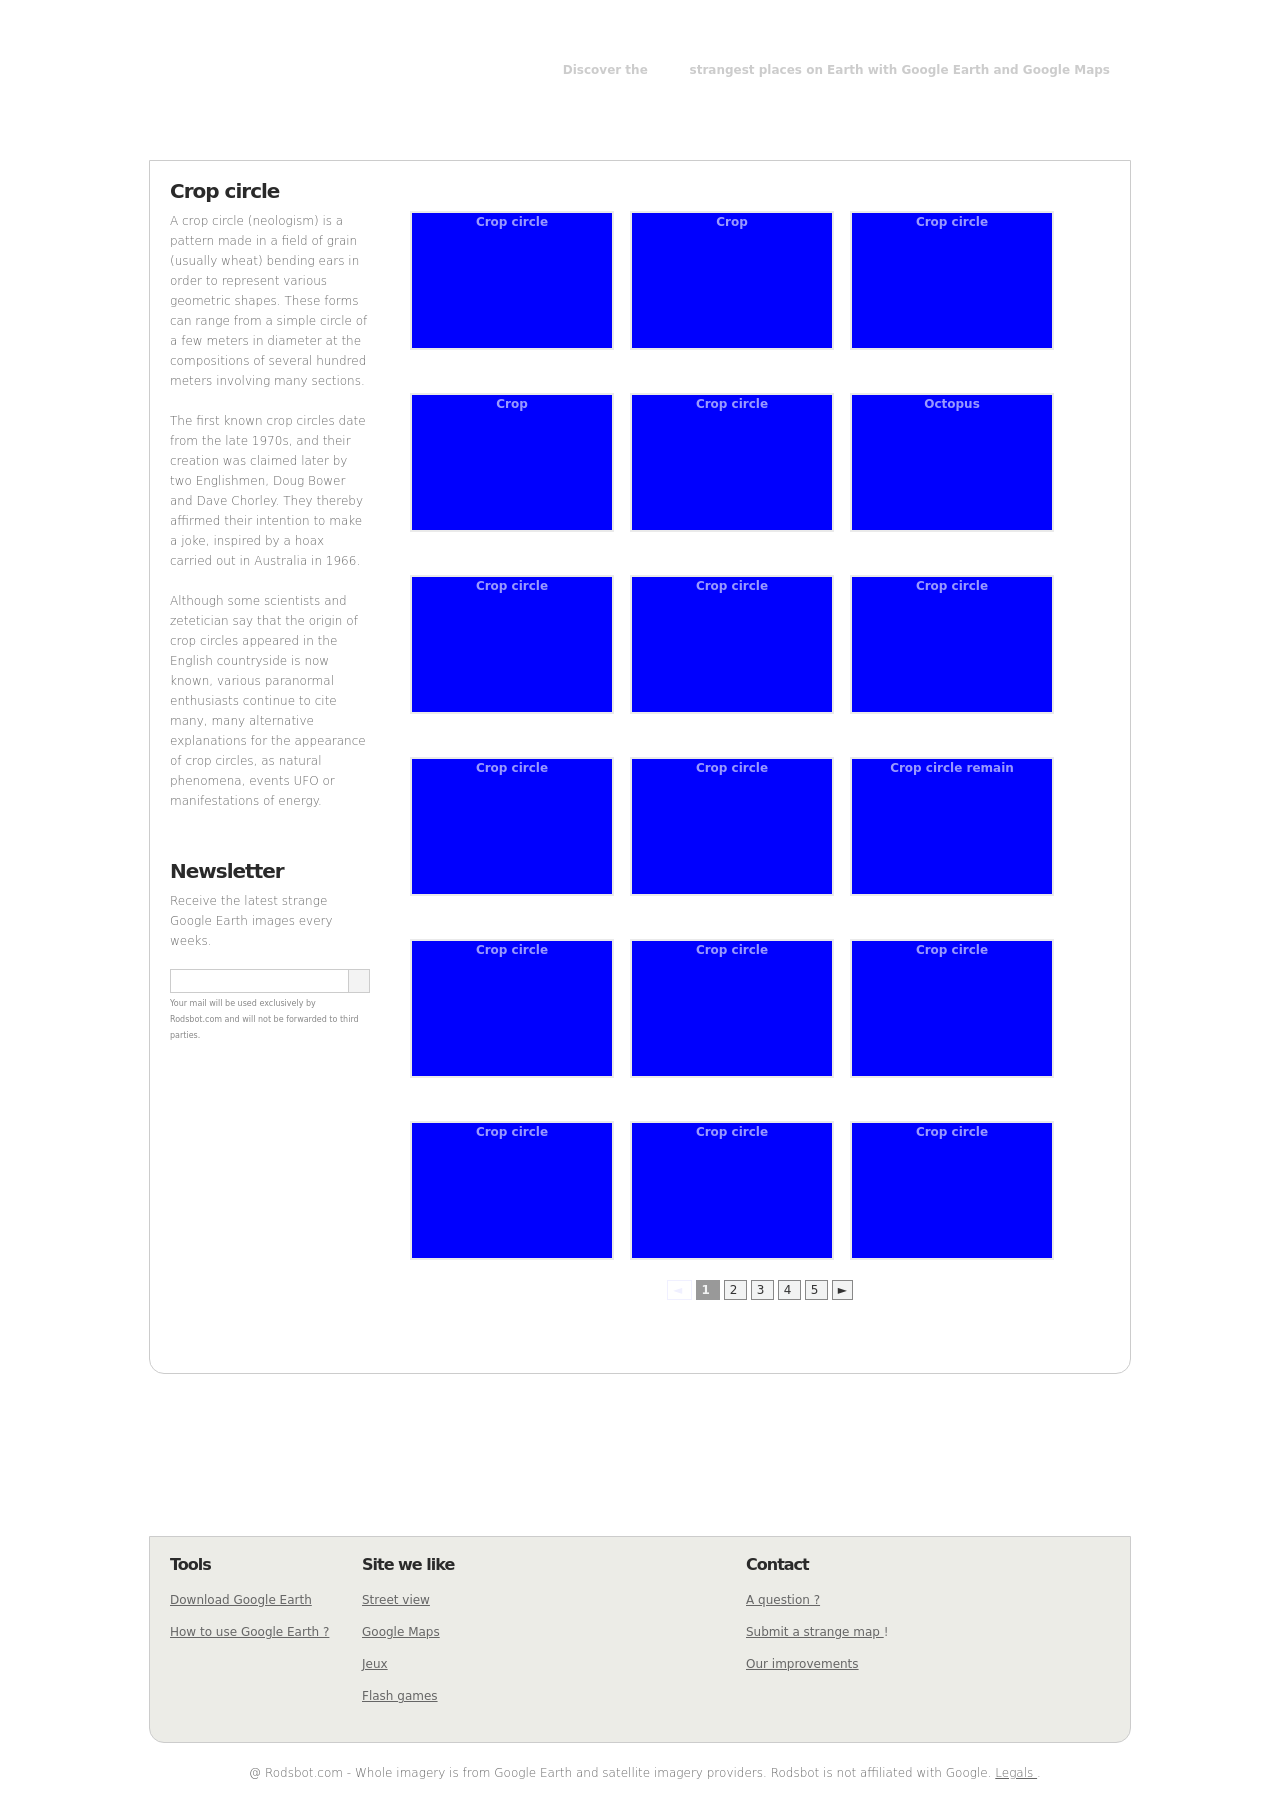What's the procedure for constructing this website from scratch with HTML? To construct a website like the one shown in the image from scratch using HTML, you would begin by defining a basic HTML structure. This includes setting up your DOCTYPE, HTML head (where you'll link your CSS files or include inline styles), and the body, where all visible content resides. For a page displaying various crop circles, use a grid layout possibly managed by CSS Grid or Flexbox to arrange images and text in a systematic format. Within the main structure, sections or divs can serve specific content zones, such as headers, navigation bars, image galleries, and footers. Associating each crop circle with an HTML card-like component, which consists of an image and possibly some descriptive text underneath, would visually represent each item cleanly. 